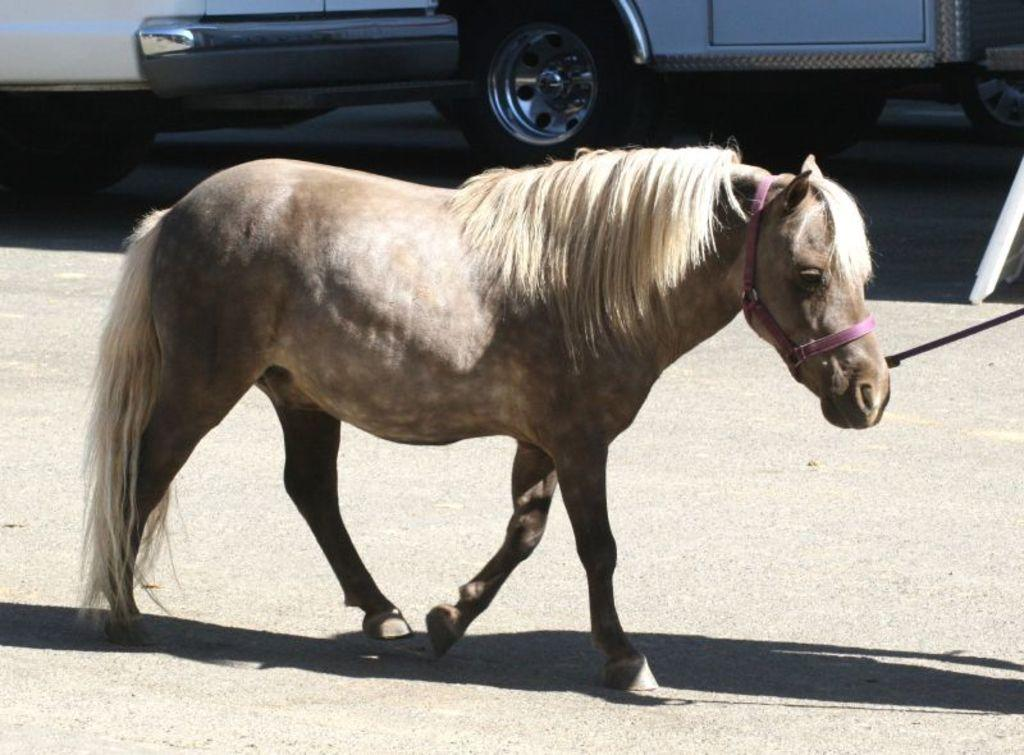What type of animal is present in the image? There is an animal in the image, but its specific type cannot be determined from the provided facts. What can be seen on the road in the image? There are vehicles on the road in the image. What type of point is being made by the cabbage in the image? There is no cabbage present in the image, so it cannot be making any point. 